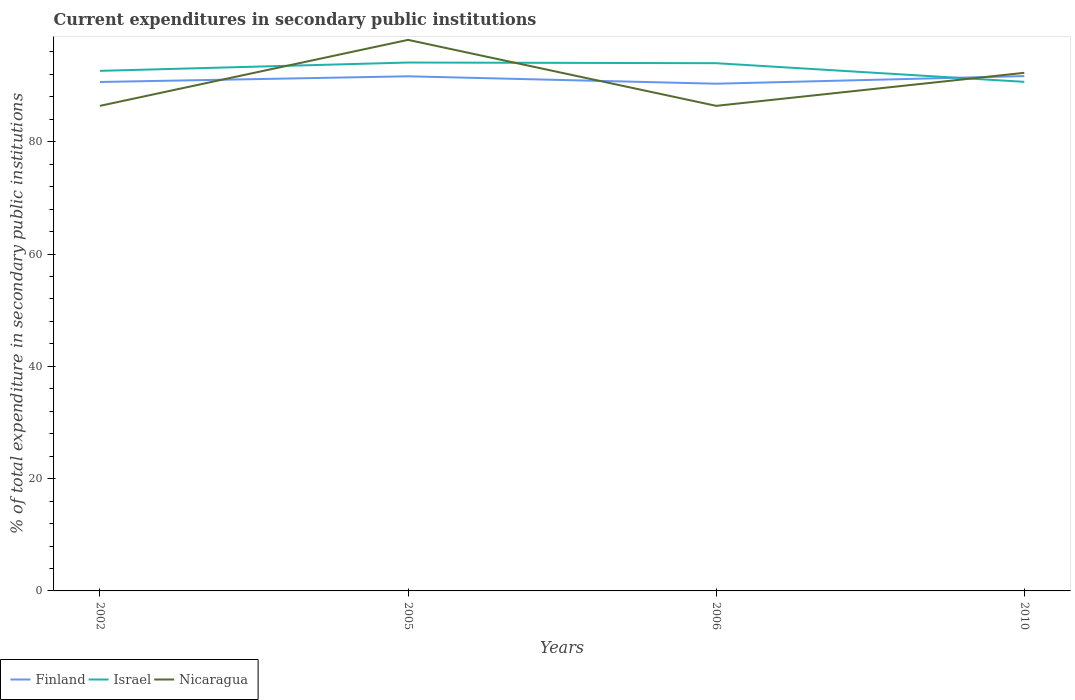Does the line corresponding to Nicaragua intersect with the line corresponding to Finland?
Offer a very short reply. Yes. Across all years, what is the maximum current expenditures in secondary public institutions in Finland?
Provide a short and direct response. 90.34. In which year was the current expenditures in secondary public institutions in Israel maximum?
Your response must be concise. 2010. What is the total current expenditures in secondary public institutions in Israel in the graph?
Your response must be concise. -1.49. What is the difference between the highest and the second highest current expenditures in secondary public institutions in Finland?
Offer a very short reply. 1.36. What is the difference between the highest and the lowest current expenditures in secondary public institutions in Nicaragua?
Provide a short and direct response. 2. Is the current expenditures in secondary public institutions in Finland strictly greater than the current expenditures in secondary public institutions in Israel over the years?
Offer a very short reply. No. What is the difference between two consecutive major ticks on the Y-axis?
Your answer should be compact. 20. Are the values on the major ticks of Y-axis written in scientific E-notation?
Your answer should be very brief. No. Does the graph contain any zero values?
Your answer should be compact. No. How are the legend labels stacked?
Keep it short and to the point. Horizontal. What is the title of the graph?
Your answer should be compact. Current expenditures in secondary public institutions. What is the label or title of the X-axis?
Make the answer very short. Years. What is the label or title of the Y-axis?
Ensure brevity in your answer.  % of total expenditure in secondary public institutions. What is the % of total expenditure in secondary public institutions in Finland in 2002?
Provide a succinct answer. 90.64. What is the % of total expenditure in secondary public institutions of Israel in 2002?
Your response must be concise. 92.62. What is the % of total expenditure in secondary public institutions of Nicaragua in 2002?
Your answer should be very brief. 86.39. What is the % of total expenditure in secondary public institutions of Finland in 2005?
Provide a succinct answer. 91.66. What is the % of total expenditure in secondary public institutions of Israel in 2005?
Your response must be concise. 94.11. What is the % of total expenditure in secondary public institutions of Nicaragua in 2005?
Make the answer very short. 98.14. What is the % of total expenditure in secondary public institutions of Finland in 2006?
Offer a terse response. 90.34. What is the % of total expenditure in secondary public institutions of Israel in 2006?
Provide a short and direct response. 93.99. What is the % of total expenditure in secondary public institutions in Nicaragua in 2006?
Your answer should be very brief. 86.39. What is the % of total expenditure in secondary public institutions of Finland in 2010?
Your answer should be compact. 91.69. What is the % of total expenditure in secondary public institutions in Israel in 2010?
Make the answer very short. 90.67. What is the % of total expenditure in secondary public institutions in Nicaragua in 2010?
Your answer should be very brief. 92.27. Across all years, what is the maximum % of total expenditure in secondary public institutions in Finland?
Your answer should be compact. 91.69. Across all years, what is the maximum % of total expenditure in secondary public institutions of Israel?
Keep it short and to the point. 94.11. Across all years, what is the maximum % of total expenditure in secondary public institutions in Nicaragua?
Provide a short and direct response. 98.14. Across all years, what is the minimum % of total expenditure in secondary public institutions of Finland?
Your answer should be compact. 90.34. Across all years, what is the minimum % of total expenditure in secondary public institutions of Israel?
Give a very brief answer. 90.67. Across all years, what is the minimum % of total expenditure in secondary public institutions in Nicaragua?
Provide a succinct answer. 86.39. What is the total % of total expenditure in secondary public institutions of Finland in the graph?
Provide a short and direct response. 364.33. What is the total % of total expenditure in secondary public institutions in Israel in the graph?
Offer a very short reply. 371.4. What is the total % of total expenditure in secondary public institutions in Nicaragua in the graph?
Make the answer very short. 363.21. What is the difference between the % of total expenditure in secondary public institutions of Finland in 2002 and that in 2005?
Make the answer very short. -1.01. What is the difference between the % of total expenditure in secondary public institutions of Israel in 2002 and that in 2005?
Offer a very short reply. -1.49. What is the difference between the % of total expenditure in secondary public institutions of Nicaragua in 2002 and that in 2005?
Ensure brevity in your answer.  -11.75. What is the difference between the % of total expenditure in secondary public institutions of Finland in 2002 and that in 2006?
Provide a succinct answer. 0.31. What is the difference between the % of total expenditure in secondary public institutions in Israel in 2002 and that in 2006?
Make the answer very short. -1.37. What is the difference between the % of total expenditure in secondary public institutions in Nicaragua in 2002 and that in 2006?
Offer a very short reply. -0. What is the difference between the % of total expenditure in secondary public institutions in Finland in 2002 and that in 2010?
Your answer should be very brief. -1.05. What is the difference between the % of total expenditure in secondary public institutions of Israel in 2002 and that in 2010?
Your answer should be very brief. 1.95. What is the difference between the % of total expenditure in secondary public institutions of Nicaragua in 2002 and that in 2010?
Your answer should be compact. -5.88. What is the difference between the % of total expenditure in secondary public institutions in Finland in 2005 and that in 2006?
Provide a short and direct response. 1.32. What is the difference between the % of total expenditure in secondary public institutions in Israel in 2005 and that in 2006?
Keep it short and to the point. 0.12. What is the difference between the % of total expenditure in secondary public institutions of Nicaragua in 2005 and that in 2006?
Keep it short and to the point. 11.75. What is the difference between the % of total expenditure in secondary public institutions in Finland in 2005 and that in 2010?
Your answer should be very brief. -0.04. What is the difference between the % of total expenditure in secondary public institutions in Israel in 2005 and that in 2010?
Provide a short and direct response. 3.44. What is the difference between the % of total expenditure in secondary public institutions in Nicaragua in 2005 and that in 2010?
Your answer should be very brief. 5.87. What is the difference between the % of total expenditure in secondary public institutions of Finland in 2006 and that in 2010?
Provide a short and direct response. -1.36. What is the difference between the % of total expenditure in secondary public institutions in Israel in 2006 and that in 2010?
Keep it short and to the point. 3.32. What is the difference between the % of total expenditure in secondary public institutions of Nicaragua in 2006 and that in 2010?
Your answer should be compact. -5.88. What is the difference between the % of total expenditure in secondary public institutions in Finland in 2002 and the % of total expenditure in secondary public institutions in Israel in 2005?
Your answer should be very brief. -3.47. What is the difference between the % of total expenditure in secondary public institutions of Finland in 2002 and the % of total expenditure in secondary public institutions of Nicaragua in 2005?
Ensure brevity in your answer.  -7.5. What is the difference between the % of total expenditure in secondary public institutions in Israel in 2002 and the % of total expenditure in secondary public institutions in Nicaragua in 2005?
Your answer should be compact. -5.52. What is the difference between the % of total expenditure in secondary public institutions in Finland in 2002 and the % of total expenditure in secondary public institutions in Israel in 2006?
Give a very brief answer. -3.35. What is the difference between the % of total expenditure in secondary public institutions of Finland in 2002 and the % of total expenditure in secondary public institutions of Nicaragua in 2006?
Your response must be concise. 4.25. What is the difference between the % of total expenditure in secondary public institutions in Israel in 2002 and the % of total expenditure in secondary public institutions in Nicaragua in 2006?
Your answer should be very brief. 6.23. What is the difference between the % of total expenditure in secondary public institutions of Finland in 2002 and the % of total expenditure in secondary public institutions of Israel in 2010?
Give a very brief answer. -0.03. What is the difference between the % of total expenditure in secondary public institutions in Finland in 2002 and the % of total expenditure in secondary public institutions in Nicaragua in 2010?
Your response must be concise. -1.63. What is the difference between the % of total expenditure in secondary public institutions of Israel in 2002 and the % of total expenditure in secondary public institutions of Nicaragua in 2010?
Keep it short and to the point. 0.35. What is the difference between the % of total expenditure in secondary public institutions in Finland in 2005 and the % of total expenditure in secondary public institutions in Israel in 2006?
Provide a short and direct response. -2.33. What is the difference between the % of total expenditure in secondary public institutions in Finland in 2005 and the % of total expenditure in secondary public institutions in Nicaragua in 2006?
Provide a short and direct response. 5.26. What is the difference between the % of total expenditure in secondary public institutions of Israel in 2005 and the % of total expenditure in secondary public institutions of Nicaragua in 2006?
Your answer should be compact. 7.72. What is the difference between the % of total expenditure in secondary public institutions in Finland in 2005 and the % of total expenditure in secondary public institutions in Israel in 2010?
Provide a short and direct response. 0.99. What is the difference between the % of total expenditure in secondary public institutions of Finland in 2005 and the % of total expenditure in secondary public institutions of Nicaragua in 2010?
Your response must be concise. -0.62. What is the difference between the % of total expenditure in secondary public institutions of Israel in 2005 and the % of total expenditure in secondary public institutions of Nicaragua in 2010?
Keep it short and to the point. 1.83. What is the difference between the % of total expenditure in secondary public institutions in Finland in 2006 and the % of total expenditure in secondary public institutions in Israel in 2010?
Your answer should be very brief. -0.33. What is the difference between the % of total expenditure in secondary public institutions of Finland in 2006 and the % of total expenditure in secondary public institutions of Nicaragua in 2010?
Ensure brevity in your answer.  -1.94. What is the difference between the % of total expenditure in secondary public institutions in Israel in 2006 and the % of total expenditure in secondary public institutions in Nicaragua in 2010?
Your answer should be very brief. 1.72. What is the average % of total expenditure in secondary public institutions in Finland per year?
Make the answer very short. 91.08. What is the average % of total expenditure in secondary public institutions of Israel per year?
Your answer should be very brief. 92.85. What is the average % of total expenditure in secondary public institutions of Nicaragua per year?
Your answer should be very brief. 90.8. In the year 2002, what is the difference between the % of total expenditure in secondary public institutions of Finland and % of total expenditure in secondary public institutions of Israel?
Ensure brevity in your answer.  -1.98. In the year 2002, what is the difference between the % of total expenditure in secondary public institutions in Finland and % of total expenditure in secondary public institutions in Nicaragua?
Provide a succinct answer. 4.25. In the year 2002, what is the difference between the % of total expenditure in secondary public institutions in Israel and % of total expenditure in secondary public institutions in Nicaragua?
Give a very brief answer. 6.23. In the year 2005, what is the difference between the % of total expenditure in secondary public institutions in Finland and % of total expenditure in secondary public institutions in Israel?
Offer a very short reply. -2.45. In the year 2005, what is the difference between the % of total expenditure in secondary public institutions of Finland and % of total expenditure in secondary public institutions of Nicaragua?
Provide a short and direct response. -6.49. In the year 2005, what is the difference between the % of total expenditure in secondary public institutions in Israel and % of total expenditure in secondary public institutions in Nicaragua?
Give a very brief answer. -4.03. In the year 2006, what is the difference between the % of total expenditure in secondary public institutions of Finland and % of total expenditure in secondary public institutions of Israel?
Make the answer very short. -3.66. In the year 2006, what is the difference between the % of total expenditure in secondary public institutions of Finland and % of total expenditure in secondary public institutions of Nicaragua?
Your answer should be compact. 3.94. In the year 2006, what is the difference between the % of total expenditure in secondary public institutions of Israel and % of total expenditure in secondary public institutions of Nicaragua?
Provide a short and direct response. 7.6. In the year 2010, what is the difference between the % of total expenditure in secondary public institutions in Finland and % of total expenditure in secondary public institutions in Israel?
Your response must be concise. 1.02. In the year 2010, what is the difference between the % of total expenditure in secondary public institutions of Finland and % of total expenditure in secondary public institutions of Nicaragua?
Give a very brief answer. -0.58. In the year 2010, what is the difference between the % of total expenditure in secondary public institutions in Israel and % of total expenditure in secondary public institutions in Nicaragua?
Provide a short and direct response. -1.61. What is the ratio of the % of total expenditure in secondary public institutions of Finland in 2002 to that in 2005?
Offer a very short reply. 0.99. What is the ratio of the % of total expenditure in secondary public institutions of Israel in 2002 to that in 2005?
Make the answer very short. 0.98. What is the ratio of the % of total expenditure in secondary public institutions of Nicaragua in 2002 to that in 2005?
Your answer should be very brief. 0.88. What is the ratio of the % of total expenditure in secondary public institutions of Israel in 2002 to that in 2006?
Provide a succinct answer. 0.99. What is the ratio of the % of total expenditure in secondary public institutions of Finland in 2002 to that in 2010?
Provide a succinct answer. 0.99. What is the ratio of the % of total expenditure in secondary public institutions in Israel in 2002 to that in 2010?
Offer a very short reply. 1.02. What is the ratio of the % of total expenditure in secondary public institutions in Nicaragua in 2002 to that in 2010?
Offer a terse response. 0.94. What is the ratio of the % of total expenditure in secondary public institutions in Finland in 2005 to that in 2006?
Give a very brief answer. 1.01. What is the ratio of the % of total expenditure in secondary public institutions in Israel in 2005 to that in 2006?
Give a very brief answer. 1. What is the ratio of the % of total expenditure in secondary public institutions in Nicaragua in 2005 to that in 2006?
Your answer should be compact. 1.14. What is the ratio of the % of total expenditure in secondary public institutions in Finland in 2005 to that in 2010?
Give a very brief answer. 1. What is the ratio of the % of total expenditure in secondary public institutions in Israel in 2005 to that in 2010?
Your answer should be compact. 1.04. What is the ratio of the % of total expenditure in secondary public institutions in Nicaragua in 2005 to that in 2010?
Offer a terse response. 1.06. What is the ratio of the % of total expenditure in secondary public institutions of Finland in 2006 to that in 2010?
Give a very brief answer. 0.99. What is the ratio of the % of total expenditure in secondary public institutions in Israel in 2006 to that in 2010?
Provide a succinct answer. 1.04. What is the ratio of the % of total expenditure in secondary public institutions of Nicaragua in 2006 to that in 2010?
Make the answer very short. 0.94. What is the difference between the highest and the second highest % of total expenditure in secondary public institutions in Finland?
Your answer should be very brief. 0.04. What is the difference between the highest and the second highest % of total expenditure in secondary public institutions of Israel?
Your response must be concise. 0.12. What is the difference between the highest and the second highest % of total expenditure in secondary public institutions of Nicaragua?
Provide a succinct answer. 5.87. What is the difference between the highest and the lowest % of total expenditure in secondary public institutions of Finland?
Ensure brevity in your answer.  1.36. What is the difference between the highest and the lowest % of total expenditure in secondary public institutions of Israel?
Your answer should be very brief. 3.44. What is the difference between the highest and the lowest % of total expenditure in secondary public institutions of Nicaragua?
Offer a terse response. 11.75. 